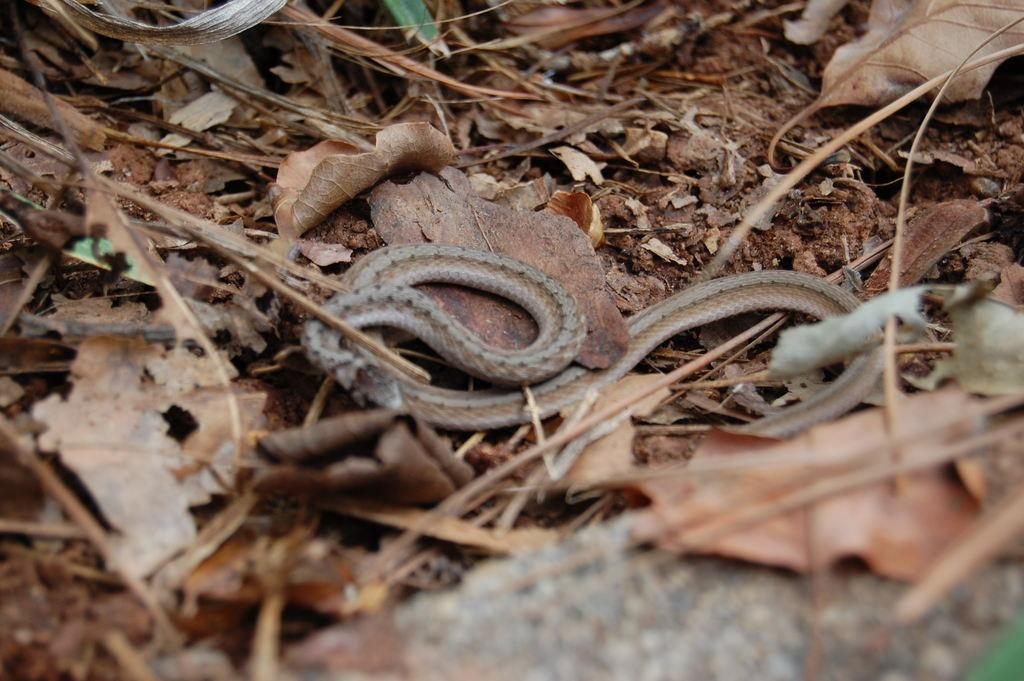What type of animal can be seen in the image? There is a snake in the image. What natural elements are present in the image? Leaves and sticks are visible in the image. When was the image taken? The image was taken during the day. Where is the seashore located in the image? There is no seashore present in the image; it features a snake, leaves, and sticks. What type of badge is being worn by the snake in the image? There is no badge present in the image, as it features a snake, leaves, and sticks. 